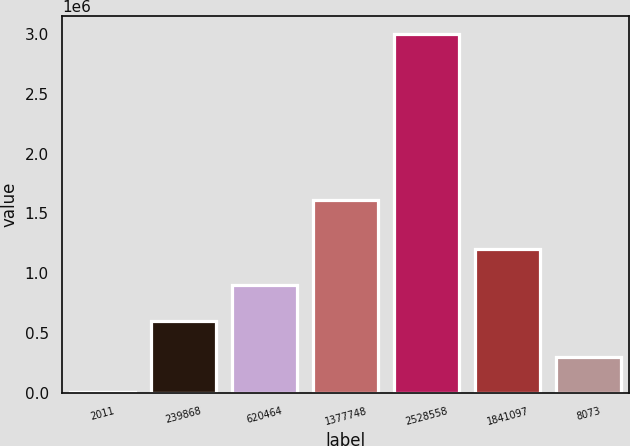Convert chart to OTSL. <chart><loc_0><loc_0><loc_500><loc_500><bar_chart><fcel>2011<fcel>239868<fcel>620464<fcel>1377748<fcel>2528558<fcel>1841097<fcel>8073<nl><fcel>2010<fcel>601422<fcel>901129<fcel>1.61574e+06<fcel>2.99907e+06<fcel>1.20083e+06<fcel>301716<nl></chart> 